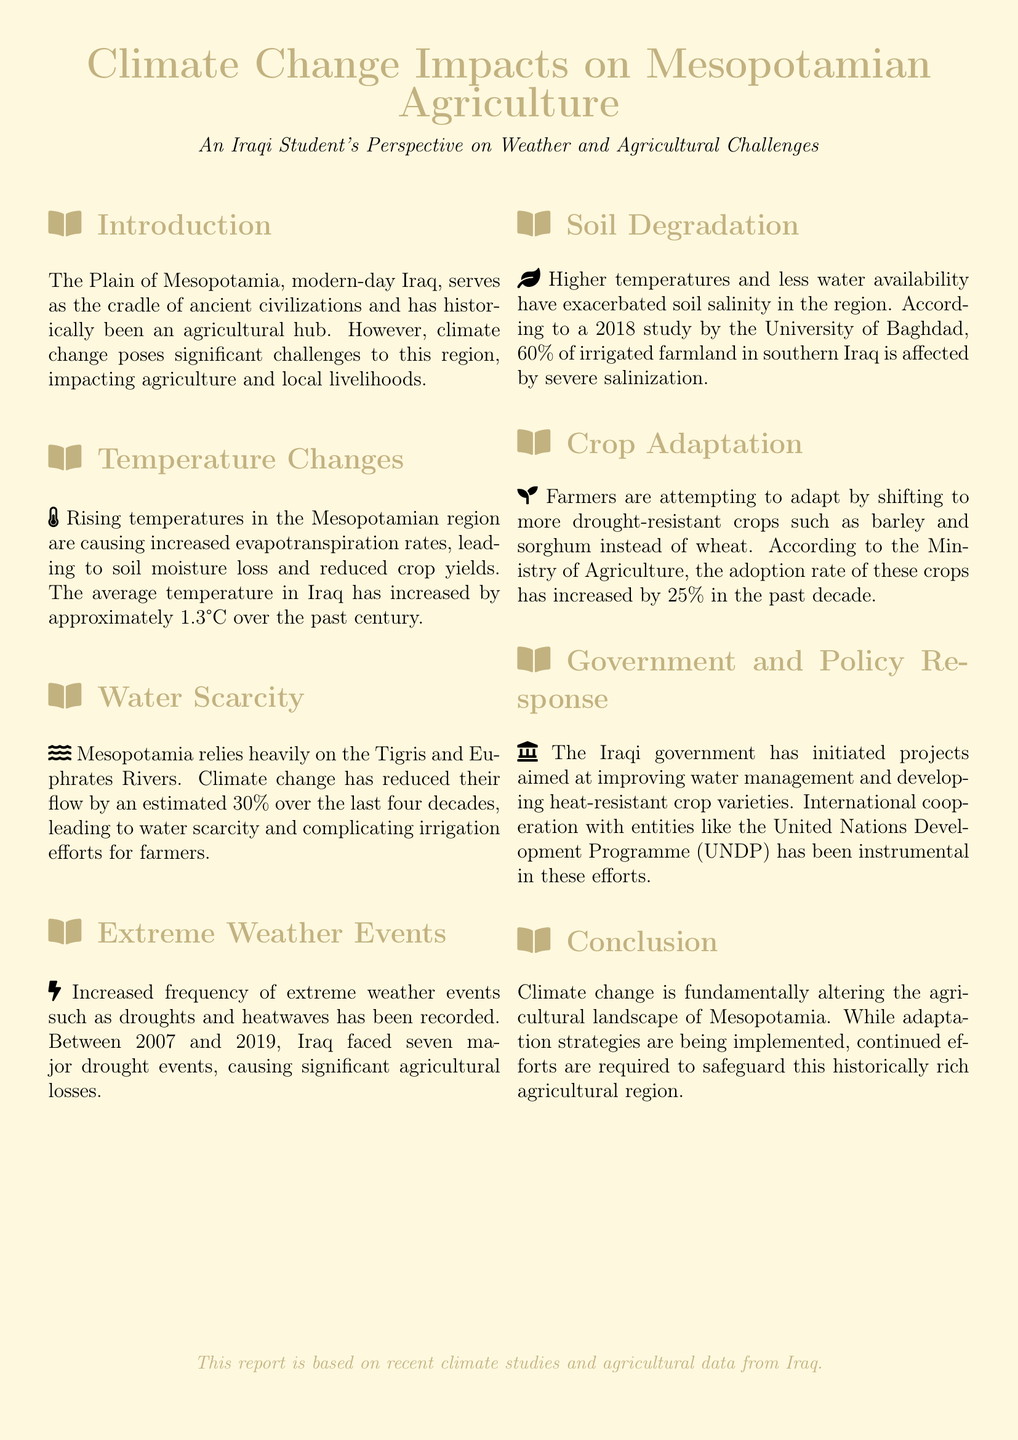What is the average temperature increase in Iraq over the past century? The document states that the average temperature in Iraq has increased by approximately 1.3°C over the past century.
Answer: 1.3°C What percentage has the flow of the Tigris and Euphrates Rivers reduced? The document mentions that climate change has reduced their flow by an estimated 30% over the last four decades.
Answer: 30% How many major drought events did Iraq face between 2007 and 2019? According to the document, Iraq faced seven major drought events between 2007 and 2019.
Answer: Seven What percentage of irrigated farmland in southern Iraq is affected by severe salinization? The document notes that 60% of irrigated farmland in southern Iraq is affected by severe salinization.
Answer: 60% By what percentage has the adoption rate of drought-resistant crops increased in the past decade? The document states that the adoption rate of drought-resistant crops has increased by 25% in the past decade.
Answer: 25% What type of crops are farmers shifting to in response to climate change? According to the document, farmers are shifting to more drought-resistant crops such as barley and sorghum instead of wheat.
Answer: Barley and sorghum What entity is mentioned as being instrumental in water management projects? The document references international cooperation with the United Nations Development Programme (UNDP) as instrumental in these efforts.
Answer: United Nations Development Programme (UNDP) What issue has been exacerbated by higher temperatures according to the document? The document indicates that higher temperatures have exacerbated soil salinity in the region.
Answer: Soil salinity What is the primary focus of the document? The document focuses on the impacts of climate change on agriculture in the Mesopotamian region.
Answer: Climate change impacts on agriculture 